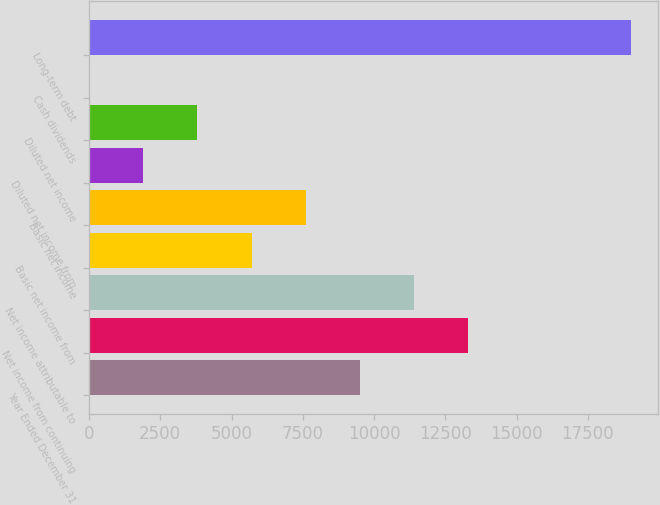Convert chart to OTSL. <chart><loc_0><loc_0><loc_500><loc_500><bar_chart><fcel>Year Ended December 31<fcel>Net income from continuing<fcel>Net income attributable to<fcel>Basic net income from<fcel>Basic net income<fcel>Diluted net income from<fcel>Diluted net income<fcel>Cash dividends<fcel>Long-term debt<nl><fcel>9505.62<fcel>13307.4<fcel>11406.5<fcel>5703.86<fcel>7604.74<fcel>1902.1<fcel>3802.98<fcel>1.22<fcel>19010<nl></chart> 